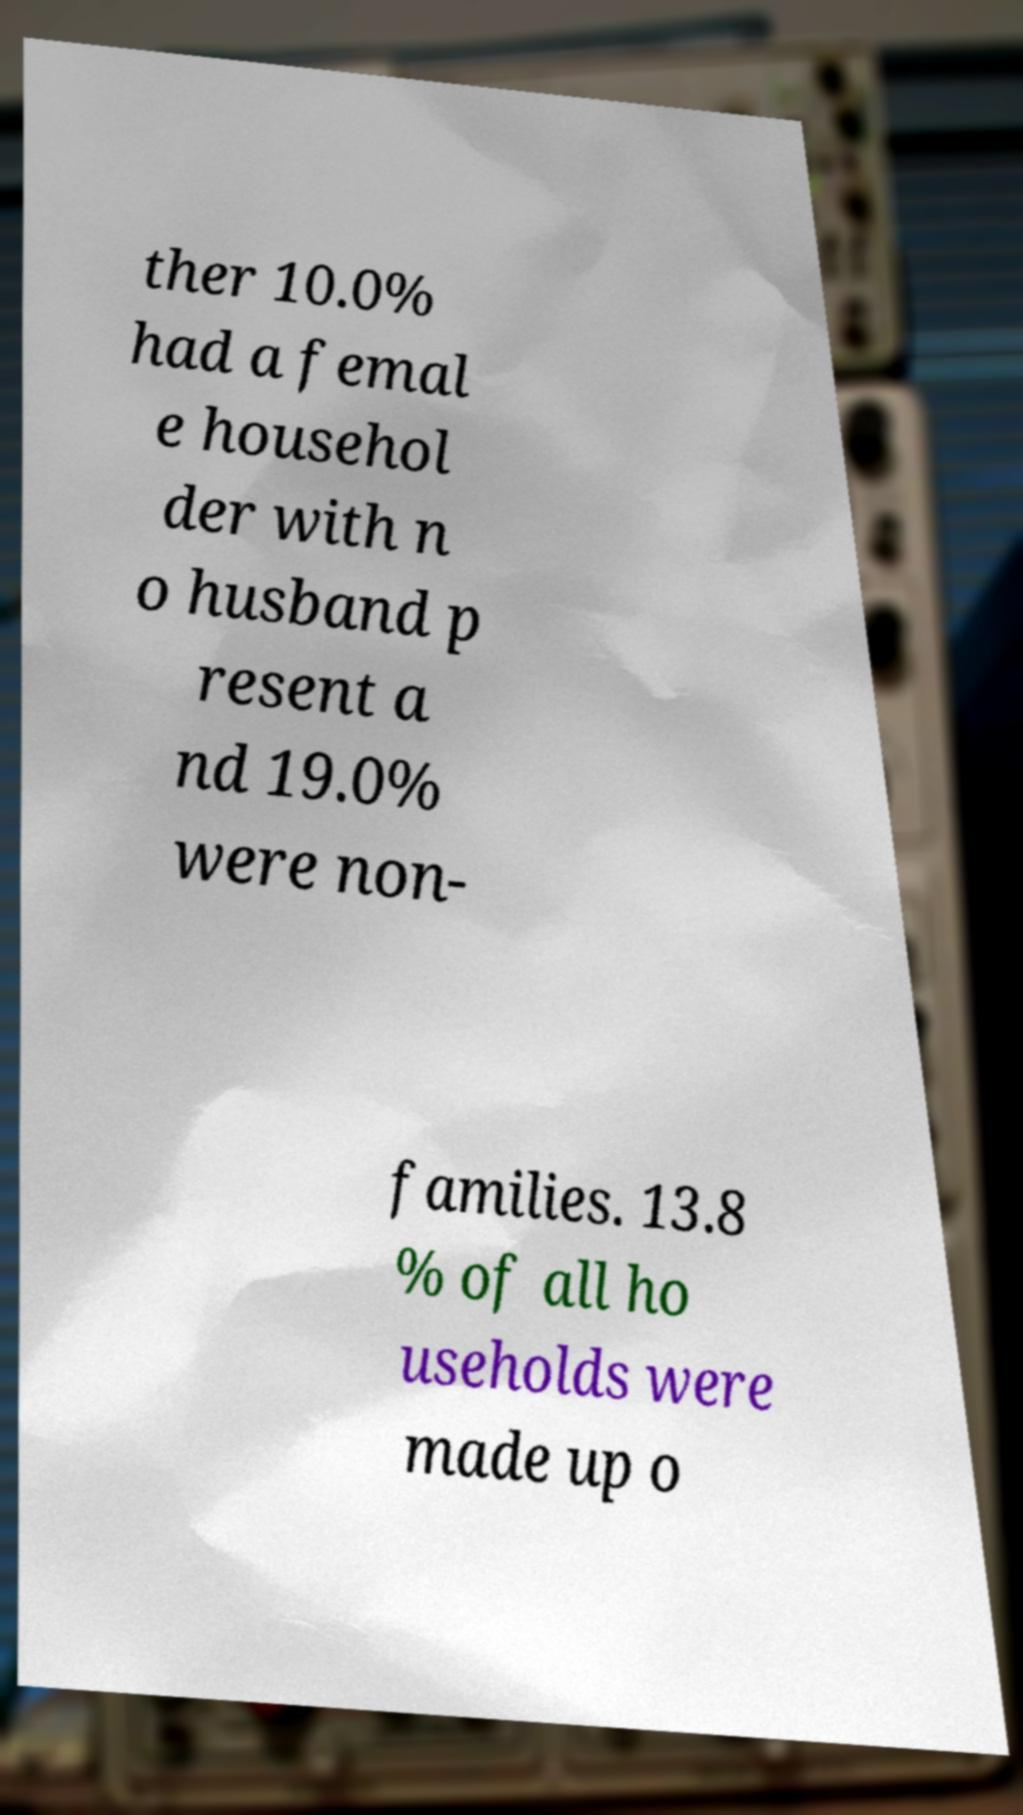I need the written content from this picture converted into text. Can you do that? ther 10.0% had a femal e househol der with n o husband p resent a nd 19.0% were non- families. 13.8 % of all ho useholds were made up o 